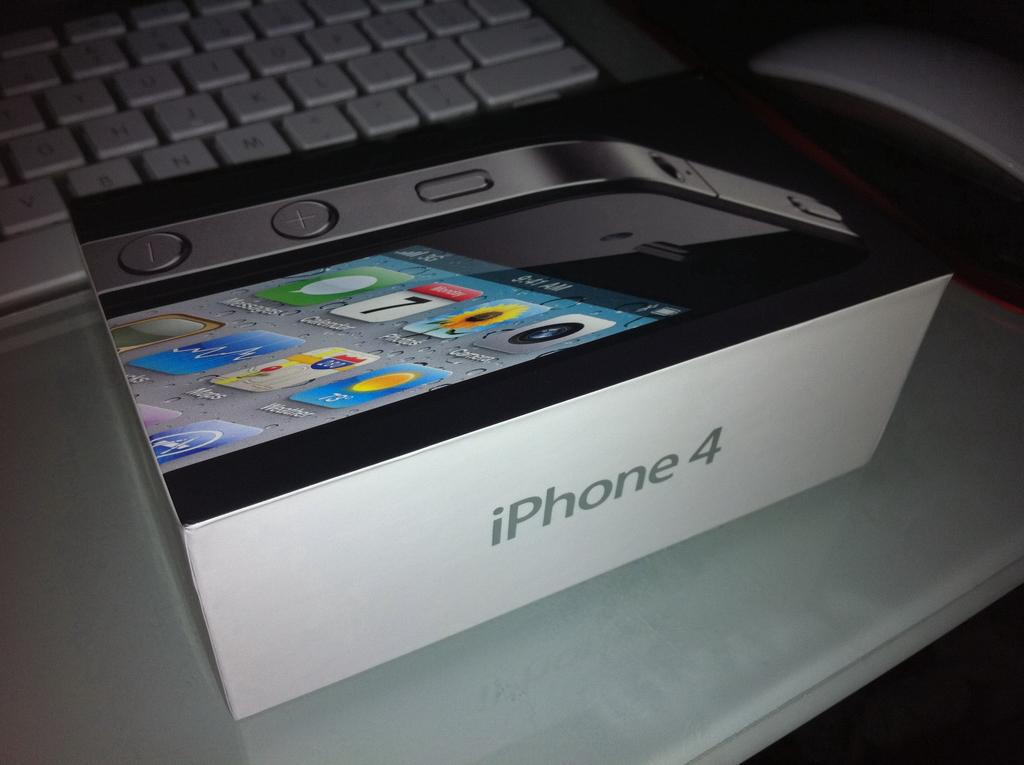<image>
Relay a brief, clear account of the picture shown. A white iPhone 4 packaging box sits on a desk next to a keyboard. 